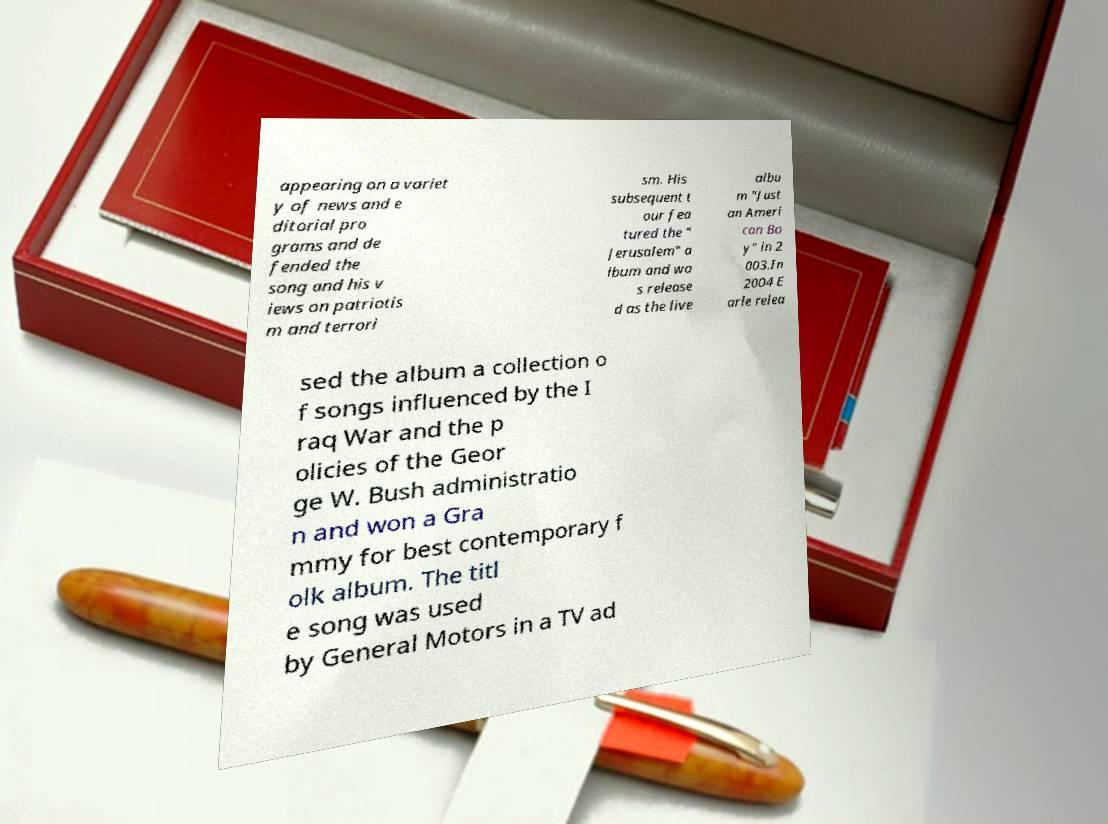What messages or text are displayed in this image? I need them in a readable, typed format. appearing on a variet y of news and e ditorial pro grams and de fended the song and his v iews on patriotis m and terrori sm. His subsequent t our fea tured the " Jerusalem" a lbum and wa s release d as the live albu m "Just an Ameri can Bo y" in 2 003.In 2004 E arle relea sed the album a collection o f songs influenced by the I raq War and the p olicies of the Geor ge W. Bush administratio n and won a Gra mmy for best contemporary f olk album. The titl e song was used by General Motors in a TV ad 